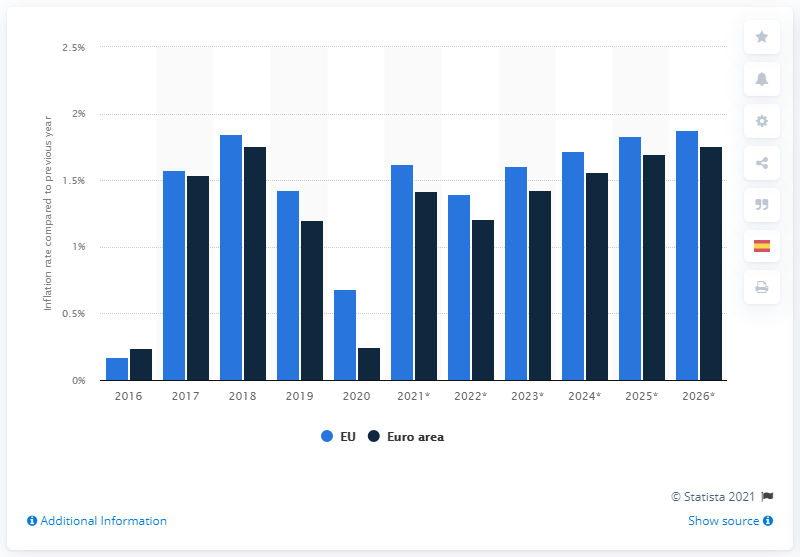Mention a couple of crucial points in this snapshot. In 2020, the inflation rate in the European Union and the Euro area came to an end. In 2020, the inflation rate in the European Union was 0.68%. 